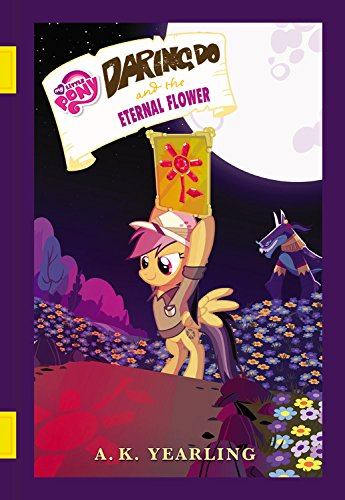Who wrote this book? The book was written by G. M. Berrow, who uses the alias 'A. K. Yearling' for the My Little Pony series. 